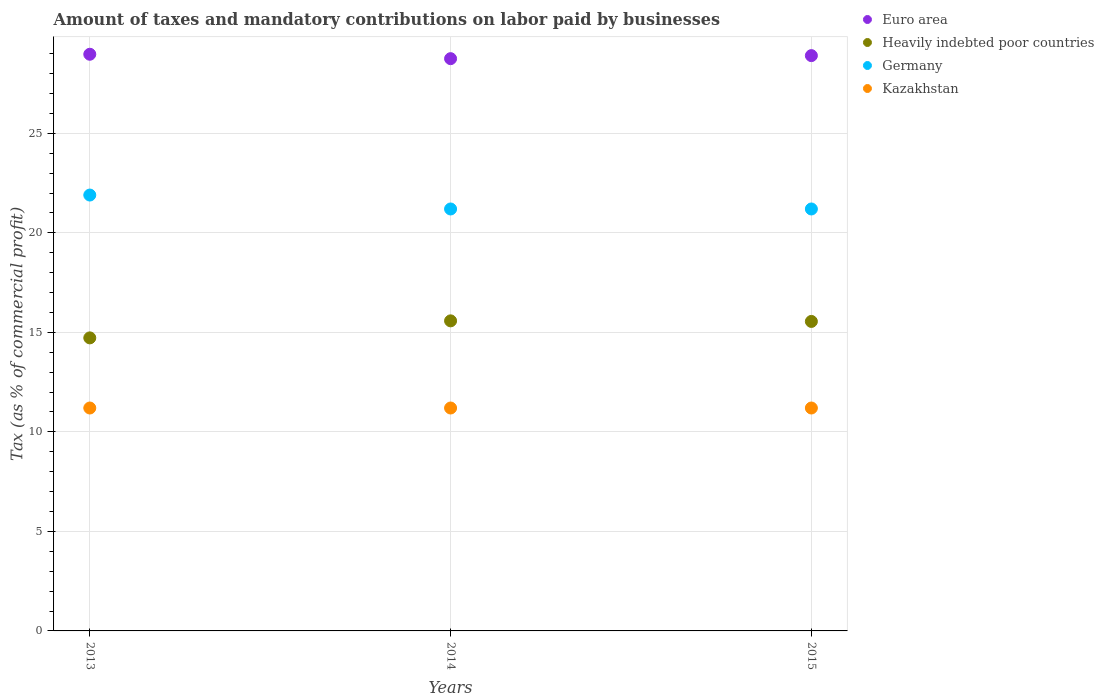How many different coloured dotlines are there?
Make the answer very short. 4. What is the percentage of taxes paid by businesses in Euro area in 2013?
Your response must be concise. 28.97. Across all years, what is the maximum percentage of taxes paid by businesses in Germany?
Offer a terse response. 21.9. Across all years, what is the minimum percentage of taxes paid by businesses in Heavily indebted poor countries?
Offer a terse response. 14.72. What is the total percentage of taxes paid by businesses in Germany in the graph?
Provide a short and direct response. 64.3. What is the difference between the percentage of taxes paid by businesses in Kazakhstan in 2015 and the percentage of taxes paid by businesses in Euro area in 2014?
Provide a short and direct response. -17.55. What is the average percentage of taxes paid by businesses in Germany per year?
Ensure brevity in your answer.  21.43. In the year 2013, what is the difference between the percentage of taxes paid by businesses in Heavily indebted poor countries and percentage of taxes paid by businesses in Kazakhstan?
Your answer should be very brief. 3.52. What is the ratio of the percentage of taxes paid by businesses in Heavily indebted poor countries in 2013 to that in 2015?
Your answer should be very brief. 0.95. Is the percentage of taxes paid by businesses in Euro area in 2013 less than that in 2015?
Ensure brevity in your answer.  No. Is the difference between the percentage of taxes paid by businesses in Heavily indebted poor countries in 2013 and 2014 greater than the difference between the percentage of taxes paid by businesses in Kazakhstan in 2013 and 2014?
Give a very brief answer. No. What is the difference between the highest and the lowest percentage of taxes paid by businesses in Germany?
Keep it short and to the point. 0.7. Is the sum of the percentage of taxes paid by businesses in Germany in 2013 and 2015 greater than the maximum percentage of taxes paid by businesses in Euro area across all years?
Your answer should be very brief. Yes. Is it the case that in every year, the sum of the percentage of taxes paid by businesses in Kazakhstan and percentage of taxes paid by businesses in Germany  is greater than the percentage of taxes paid by businesses in Heavily indebted poor countries?
Keep it short and to the point. Yes. Is the percentage of taxes paid by businesses in Euro area strictly less than the percentage of taxes paid by businesses in Heavily indebted poor countries over the years?
Give a very brief answer. No. How many dotlines are there?
Keep it short and to the point. 4. Does the graph contain any zero values?
Keep it short and to the point. No. Does the graph contain grids?
Offer a terse response. Yes. What is the title of the graph?
Your response must be concise. Amount of taxes and mandatory contributions on labor paid by businesses. Does "Indonesia" appear as one of the legend labels in the graph?
Offer a very short reply. No. What is the label or title of the X-axis?
Offer a terse response. Years. What is the label or title of the Y-axis?
Your answer should be compact. Tax (as % of commercial profit). What is the Tax (as % of commercial profit) in Euro area in 2013?
Keep it short and to the point. 28.97. What is the Tax (as % of commercial profit) in Heavily indebted poor countries in 2013?
Your answer should be compact. 14.72. What is the Tax (as % of commercial profit) in Germany in 2013?
Provide a succinct answer. 21.9. What is the Tax (as % of commercial profit) of Kazakhstan in 2013?
Make the answer very short. 11.2. What is the Tax (as % of commercial profit) of Euro area in 2014?
Keep it short and to the point. 28.75. What is the Tax (as % of commercial profit) in Heavily indebted poor countries in 2014?
Give a very brief answer. 15.58. What is the Tax (as % of commercial profit) of Germany in 2014?
Provide a short and direct response. 21.2. What is the Tax (as % of commercial profit) in Kazakhstan in 2014?
Give a very brief answer. 11.2. What is the Tax (as % of commercial profit) of Euro area in 2015?
Give a very brief answer. 28.91. What is the Tax (as % of commercial profit) in Heavily indebted poor countries in 2015?
Your response must be concise. 15.55. What is the Tax (as % of commercial profit) in Germany in 2015?
Offer a very short reply. 21.2. Across all years, what is the maximum Tax (as % of commercial profit) in Euro area?
Provide a short and direct response. 28.97. Across all years, what is the maximum Tax (as % of commercial profit) in Heavily indebted poor countries?
Your response must be concise. 15.58. Across all years, what is the maximum Tax (as % of commercial profit) in Germany?
Your answer should be compact. 21.9. Across all years, what is the maximum Tax (as % of commercial profit) of Kazakhstan?
Your answer should be very brief. 11.2. Across all years, what is the minimum Tax (as % of commercial profit) of Euro area?
Your answer should be very brief. 28.75. Across all years, what is the minimum Tax (as % of commercial profit) in Heavily indebted poor countries?
Your answer should be compact. 14.72. Across all years, what is the minimum Tax (as % of commercial profit) in Germany?
Give a very brief answer. 21.2. Across all years, what is the minimum Tax (as % of commercial profit) of Kazakhstan?
Your answer should be compact. 11.2. What is the total Tax (as % of commercial profit) in Euro area in the graph?
Your response must be concise. 86.63. What is the total Tax (as % of commercial profit) of Heavily indebted poor countries in the graph?
Make the answer very short. 45.85. What is the total Tax (as % of commercial profit) of Germany in the graph?
Your answer should be compact. 64.3. What is the total Tax (as % of commercial profit) of Kazakhstan in the graph?
Offer a terse response. 33.6. What is the difference between the Tax (as % of commercial profit) in Euro area in 2013 and that in 2014?
Keep it short and to the point. 0.22. What is the difference between the Tax (as % of commercial profit) of Heavily indebted poor countries in 2013 and that in 2014?
Give a very brief answer. -0.86. What is the difference between the Tax (as % of commercial profit) of Germany in 2013 and that in 2014?
Your response must be concise. 0.7. What is the difference between the Tax (as % of commercial profit) of Euro area in 2013 and that in 2015?
Offer a terse response. 0.07. What is the difference between the Tax (as % of commercial profit) in Heavily indebted poor countries in 2013 and that in 2015?
Ensure brevity in your answer.  -0.83. What is the difference between the Tax (as % of commercial profit) in Kazakhstan in 2013 and that in 2015?
Offer a terse response. 0. What is the difference between the Tax (as % of commercial profit) of Euro area in 2014 and that in 2015?
Offer a terse response. -0.15. What is the difference between the Tax (as % of commercial profit) in Heavily indebted poor countries in 2014 and that in 2015?
Provide a short and direct response. 0.03. What is the difference between the Tax (as % of commercial profit) of Germany in 2014 and that in 2015?
Offer a very short reply. 0. What is the difference between the Tax (as % of commercial profit) of Euro area in 2013 and the Tax (as % of commercial profit) of Heavily indebted poor countries in 2014?
Provide a short and direct response. 13.39. What is the difference between the Tax (as % of commercial profit) in Euro area in 2013 and the Tax (as % of commercial profit) in Germany in 2014?
Offer a terse response. 7.77. What is the difference between the Tax (as % of commercial profit) of Euro area in 2013 and the Tax (as % of commercial profit) of Kazakhstan in 2014?
Ensure brevity in your answer.  17.77. What is the difference between the Tax (as % of commercial profit) in Heavily indebted poor countries in 2013 and the Tax (as % of commercial profit) in Germany in 2014?
Your answer should be very brief. -6.48. What is the difference between the Tax (as % of commercial profit) in Heavily indebted poor countries in 2013 and the Tax (as % of commercial profit) in Kazakhstan in 2014?
Provide a short and direct response. 3.52. What is the difference between the Tax (as % of commercial profit) of Germany in 2013 and the Tax (as % of commercial profit) of Kazakhstan in 2014?
Offer a very short reply. 10.7. What is the difference between the Tax (as % of commercial profit) of Euro area in 2013 and the Tax (as % of commercial profit) of Heavily indebted poor countries in 2015?
Provide a short and direct response. 13.42. What is the difference between the Tax (as % of commercial profit) of Euro area in 2013 and the Tax (as % of commercial profit) of Germany in 2015?
Provide a succinct answer. 7.77. What is the difference between the Tax (as % of commercial profit) of Euro area in 2013 and the Tax (as % of commercial profit) of Kazakhstan in 2015?
Offer a very short reply. 17.77. What is the difference between the Tax (as % of commercial profit) of Heavily indebted poor countries in 2013 and the Tax (as % of commercial profit) of Germany in 2015?
Ensure brevity in your answer.  -6.48. What is the difference between the Tax (as % of commercial profit) in Heavily indebted poor countries in 2013 and the Tax (as % of commercial profit) in Kazakhstan in 2015?
Offer a very short reply. 3.52. What is the difference between the Tax (as % of commercial profit) in Germany in 2013 and the Tax (as % of commercial profit) in Kazakhstan in 2015?
Offer a very short reply. 10.7. What is the difference between the Tax (as % of commercial profit) in Euro area in 2014 and the Tax (as % of commercial profit) in Heavily indebted poor countries in 2015?
Ensure brevity in your answer.  13.2. What is the difference between the Tax (as % of commercial profit) of Euro area in 2014 and the Tax (as % of commercial profit) of Germany in 2015?
Give a very brief answer. 7.55. What is the difference between the Tax (as % of commercial profit) in Euro area in 2014 and the Tax (as % of commercial profit) in Kazakhstan in 2015?
Offer a very short reply. 17.55. What is the difference between the Tax (as % of commercial profit) of Heavily indebted poor countries in 2014 and the Tax (as % of commercial profit) of Germany in 2015?
Your answer should be very brief. -5.62. What is the difference between the Tax (as % of commercial profit) of Heavily indebted poor countries in 2014 and the Tax (as % of commercial profit) of Kazakhstan in 2015?
Your answer should be very brief. 4.38. What is the difference between the Tax (as % of commercial profit) of Germany in 2014 and the Tax (as % of commercial profit) of Kazakhstan in 2015?
Offer a terse response. 10. What is the average Tax (as % of commercial profit) in Euro area per year?
Offer a terse response. 28.88. What is the average Tax (as % of commercial profit) in Heavily indebted poor countries per year?
Your answer should be compact. 15.28. What is the average Tax (as % of commercial profit) of Germany per year?
Provide a short and direct response. 21.43. In the year 2013, what is the difference between the Tax (as % of commercial profit) in Euro area and Tax (as % of commercial profit) in Heavily indebted poor countries?
Your answer should be very brief. 14.25. In the year 2013, what is the difference between the Tax (as % of commercial profit) of Euro area and Tax (as % of commercial profit) of Germany?
Your answer should be very brief. 7.07. In the year 2013, what is the difference between the Tax (as % of commercial profit) in Euro area and Tax (as % of commercial profit) in Kazakhstan?
Make the answer very short. 17.77. In the year 2013, what is the difference between the Tax (as % of commercial profit) of Heavily indebted poor countries and Tax (as % of commercial profit) of Germany?
Your answer should be very brief. -7.18. In the year 2013, what is the difference between the Tax (as % of commercial profit) in Heavily indebted poor countries and Tax (as % of commercial profit) in Kazakhstan?
Your answer should be very brief. 3.52. In the year 2013, what is the difference between the Tax (as % of commercial profit) of Germany and Tax (as % of commercial profit) of Kazakhstan?
Keep it short and to the point. 10.7. In the year 2014, what is the difference between the Tax (as % of commercial profit) of Euro area and Tax (as % of commercial profit) of Heavily indebted poor countries?
Ensure brevity in your answer.  13.17. In the year 2014, what is the difference between the Tax (as % of commercial profit) in Euro area and Tax (as % of commercial profit) in Germany?
Provide a short and direct response. 7.55. In the year 2014, what is the difference between the Tax (as % of commercial profit) of Euro area and Tax (as % of commercial profit) of Kazakhstan?
Offer a terse response. 17.55. In the year 2014, what is the difference between the Tax (as % of commercial profit) of Heavily indebted poor countries and Tax (as % of commercial profit) of Germany?
Ensure brevity in your answer.  -5.62. In the year 2014, what is the difference between the Tax (as % of commercial profit) in Heavily indebted poor countries and Tax (as % of commercial profit) in Kazakhstan?
Offer a very short reply. 4.38. In the year 2015, what is the difference between the Tax (as % of commercial profit) of Euro area and Tax (as % of commercial profit) of Heavily indebted poor countries?
Make the answer very short. 13.36. In the year 2015, what is the difference between the Tax (as % of commercial profit) of Euro area and Tax (as % of commercial profit) of Germany?
Make the answer very short. 7.71. In the year 2015, what is the difference between the Tax (as % of commercial profit) of Euro area and Tax (as % of commercial profit) of Kazakhstan?
Offer a very short reply. 17.71. In the year 2015, what is the difference between the Tax (as % of commercial profit) of Heavily indebted poor countries and Tax (as % of commercial profit) of Germany?
Provide a succinct answer. -5.65. In the year 2015, what is the difference between the Tax (as % of commercial profit) in Heavily indebted poor countries and Tax (as % of commercial profit) in Kazakhstan?
Keep it short and to the point. 4.35. What is the ratio of the Tax (as % of commercial profit) in Euro area in 2013 to that in 2014?
Your response must be concise. 1.01. What is the ratio of the Tax (as % of commercial profit) in Heavily indebted poor countries in 2013 to that in 2014?
Make the answer very short. 0.95. What is the ratio of the Tax (as % of commercial profit) in Germany in 2013 to that in 2014?
Ensure brevity in your answer.  1.03. What is the ratio of the Tax (as % of commercial profit) of Kazakhstan in 2013 to that in 2014?
Your answer should be compact. 1. What is the ratio of the Tax (as % of commercial profit) in Euro area in 2013 to that in 2015?
Provide a succinct answer. 1. What is the ratio of the Tax (as % of commercial profit) of Heavily indebted poor countries in 2013 to that in 2015?
Your answer should be very brief. 0.95. What is the ratio of the Tax (as % of commercial profit) of Germany in 2013 to that in 2015?
Your response must be concise. 1.03. What is the ratio of the Tax (as % of commercial profit) of Euro area in 2014 to that in 2015?
Your answer should be very brief. 0.99. What is the ratio of the Tax (as % of commercial profit) in Heavily indebted poor countries in 2014 to that in 2015?
Ensure brevity in your answer.  1. What is the ratio of the Tax (as % of commercial profit) in Germany in 2014 to that in 2015?
Provide a short and direct response. 1. What is the difference between the highest and the second highest Tax (as % of commercial profit) in Euro area?
Your answer should be very brief. 0.07. What is the difference between the highest and the second highest Tax (as % of commercial profit) of Heavily indebted poor countries?
Provide a succinct answer. 0.03. What is the difference between the highest and the second highest Tax (as % of commercial profit) in Germany?
Provide a succinct answer. 0.7. What is the difference between the highest and the second highest Tax (as % of commercial profit) in Kazakhstan?
Your answer should be very brief. 0. What is the difference between the highest and the lowest Tax (as % of commercial profit) of Euro area?
Provide a short and direct response. 0.22. What is the difference between the highest and the lowest Tax (as % of commercial profit) in Heavily indebted poor countries?
Offer a terse response. 0.86. 